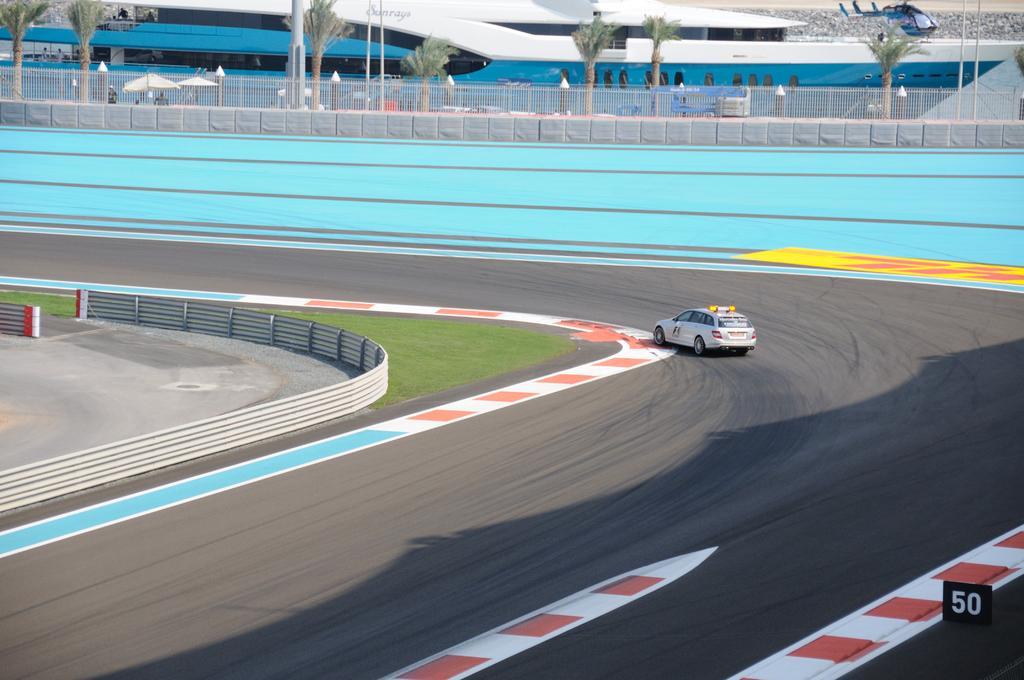In one or two sentences, can you explain what this image depicts? In this picture there is a vehicle on the road. On the left side of the image there is a railing. At the back there is a railing on the wall. Behind the railing there are umbrellas, trees and poles and there is a building and there are two persons standing behind the railing. At the back there is an aircraft. At the bottom there is grass and there is a road. At the bottom right there is a board. 